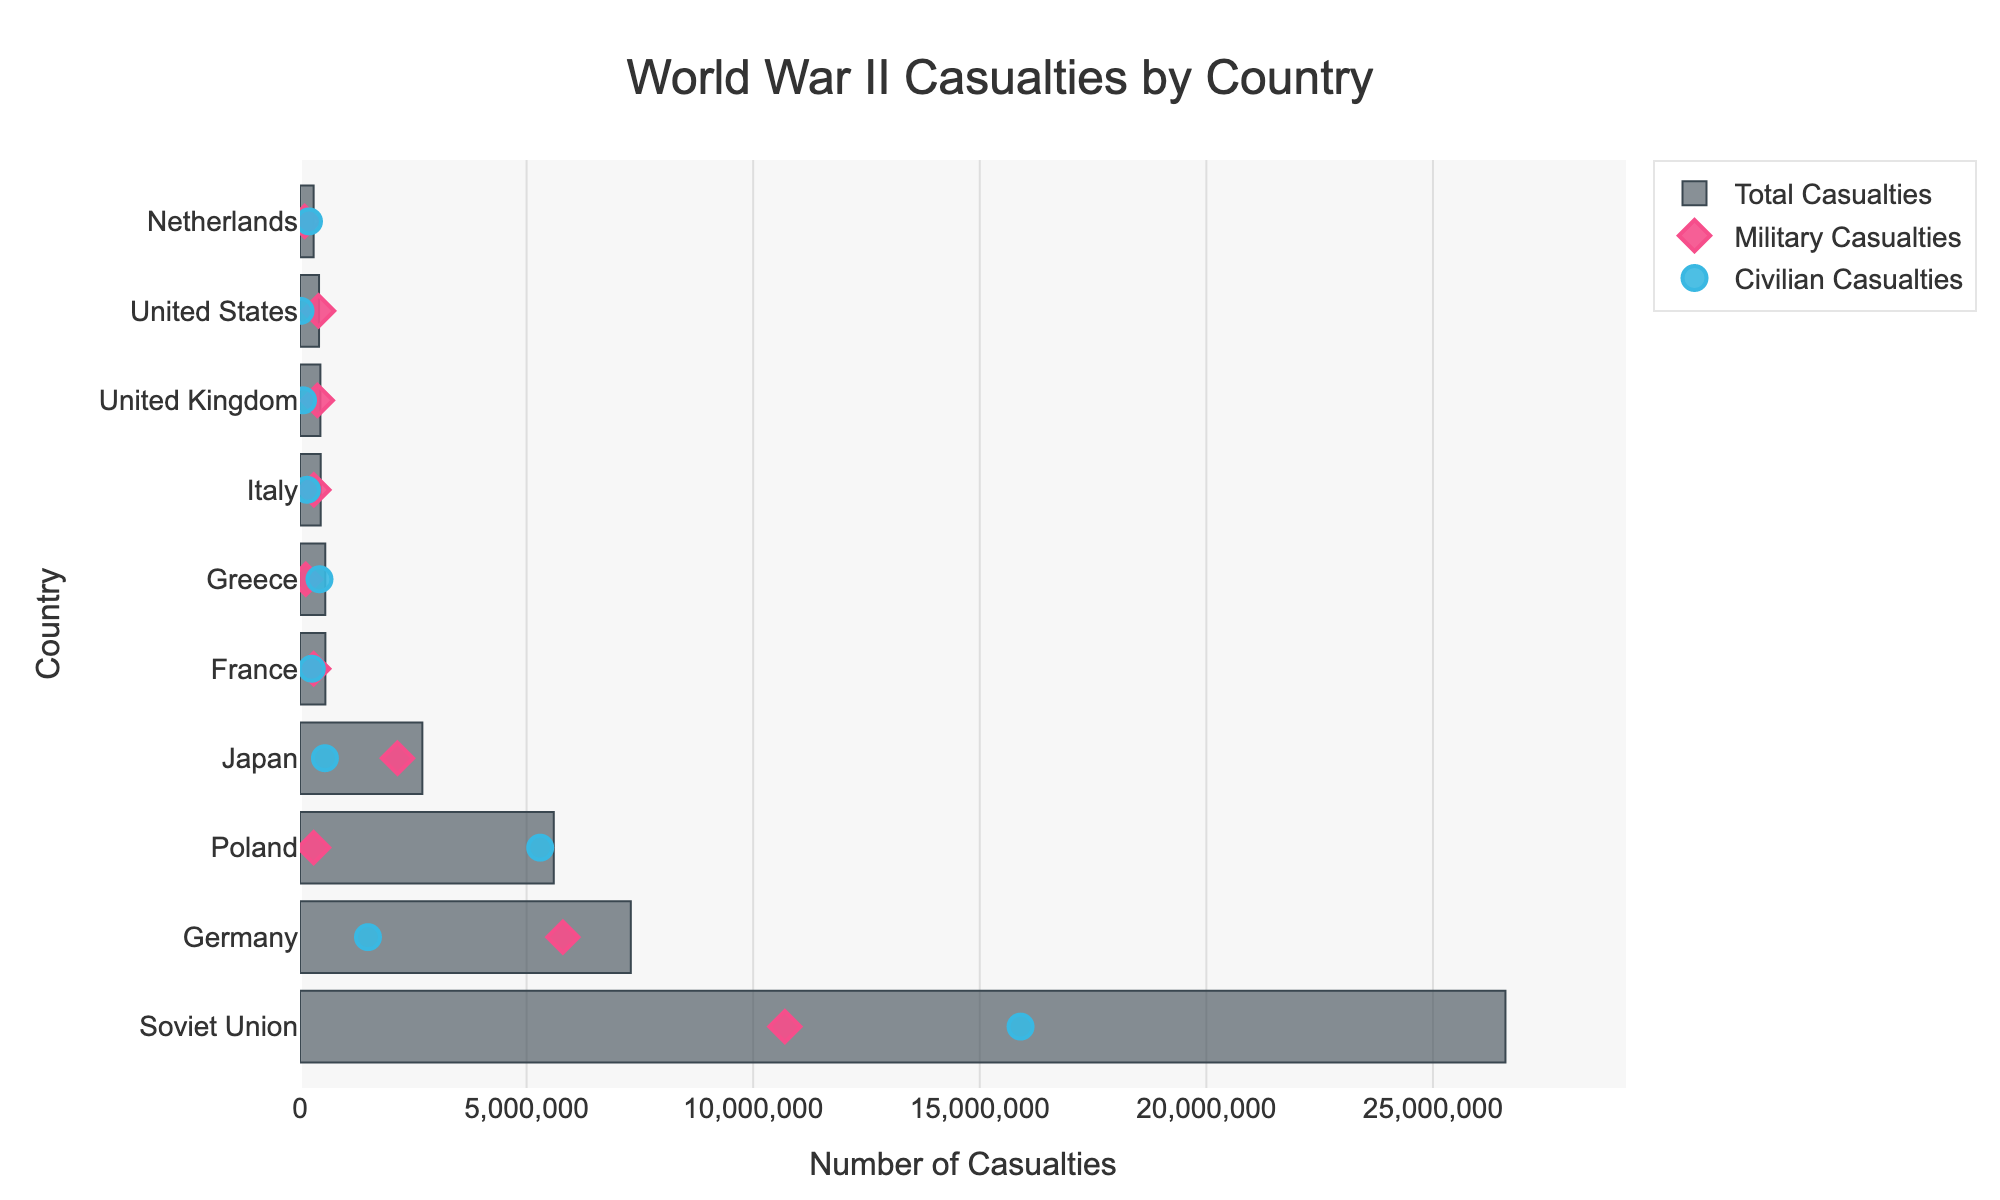Who suffered the highest number of total casualties? By looking at the length of the bars in the chart, the Soviet Union had the longest bar for total casualties, indicating that they suffered the highest number of total casualties.
Answer: Soviet Union What color represents military casualties in the figure? We can see that military casualties are represented by diamond-shaped markers in a dark pink color with a black outline.
Answer: Dark pink Which country had the highest number of civilian casualties? The scatter points representing civilian casualties show that the Soviet Union had the highest number of civilian casualties as its civilian casualty point is the furthest to the right.
Answer: Soviet Union How many countries have total casualties greater than 5 million? From the chart, we can see that the Soviet Union, Germany, and Poland each have total casualty bars extending beyond the 5 million mark, so the total is three countries.
Answer: Three What was the difference in total casualties between Germany and Japan? Germany's total casualties are 7,300,000, while Japan's are 2,700,000. Subtracting Japan's casualties from Germany's gives 7,300,000 - 2,700,000 = 4,600,000.
Answer: 4,600,000 Which country had a higher number of military casualties, France or Italy? By comparing the positions of diamond markers for France and Italy, we find that Italy's marker is further to the right, indicating a higher number of military casualties.
Answer: Italy What is the gap between civilian and military casualties in Greece? In Greece, the civilian casualties are 430,000, and the military casualties are 128,000. The gap is calculated as 430,000 - 128,000 = 302,000.
Answer: 302,000 Which country had the fewest total casualties, and how many were they? The United Kingdom's bar is the shortest among all countries in the figure, indicating the fewest total casualties, which amount to 450,000.
Answer: United Kingdom, 450,000 What percentage of the Soviet Union’s total casualties were civilian casualties? Soviet Union’s total casualties were 26,600,000 and civilian casualties were 15,900,000. The percentage is (15,900,000 / 26,600,000) × 100 ≈ 59.77%.
Answer: 59.77% Which country has a greater difference between civilian and military casualties, Poland or the Netherlands? For Poland, the difference is 5,300,000 - 300,000 = 5,000,000. For the Netherlands, the difference is 198,000 - 103,000 = 95,000. Hence, Poland has a greater difference.
Answer: Poland 